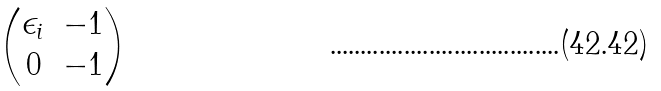Convert formula to latex. <formula><loc_0><loc_0><loc_500><loc_500>\begin{pmatrix} \epsilon _ { i } & - 1 \\ 0 & - 1 \end{pmatrix}</formula> 